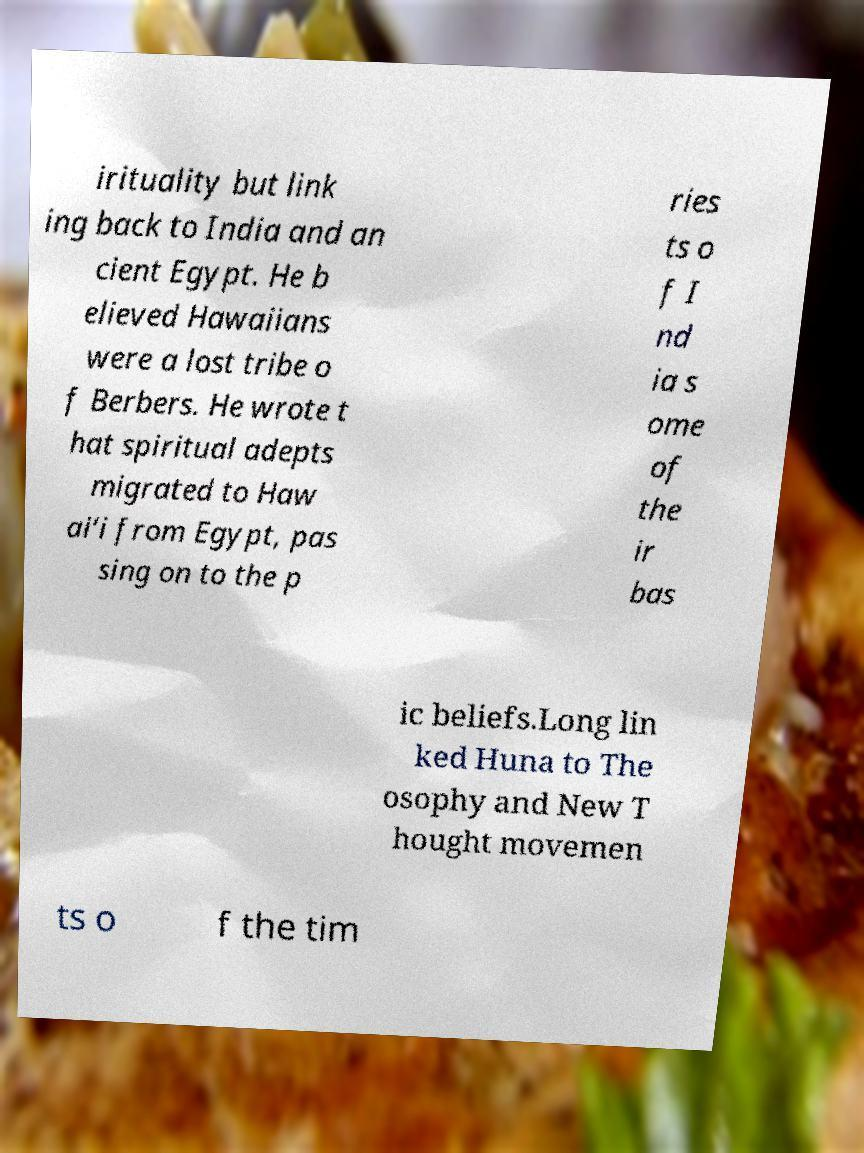What messages or text are displayed in this image? I need them in a readable, typed format. irituality but link ing back to India and an cient Egypt. He b elieved Hawaiians were a lost tribe o f Berbers. He wrote t hat spiritual adepts migrated to Haw ai‘i from Egypt, pas sing on to the p ries ts o f I nd ia s ome of the ir bas ic beliefs.Long lin ked Huna to The osophy and New T hought movemen ts o f the tim 